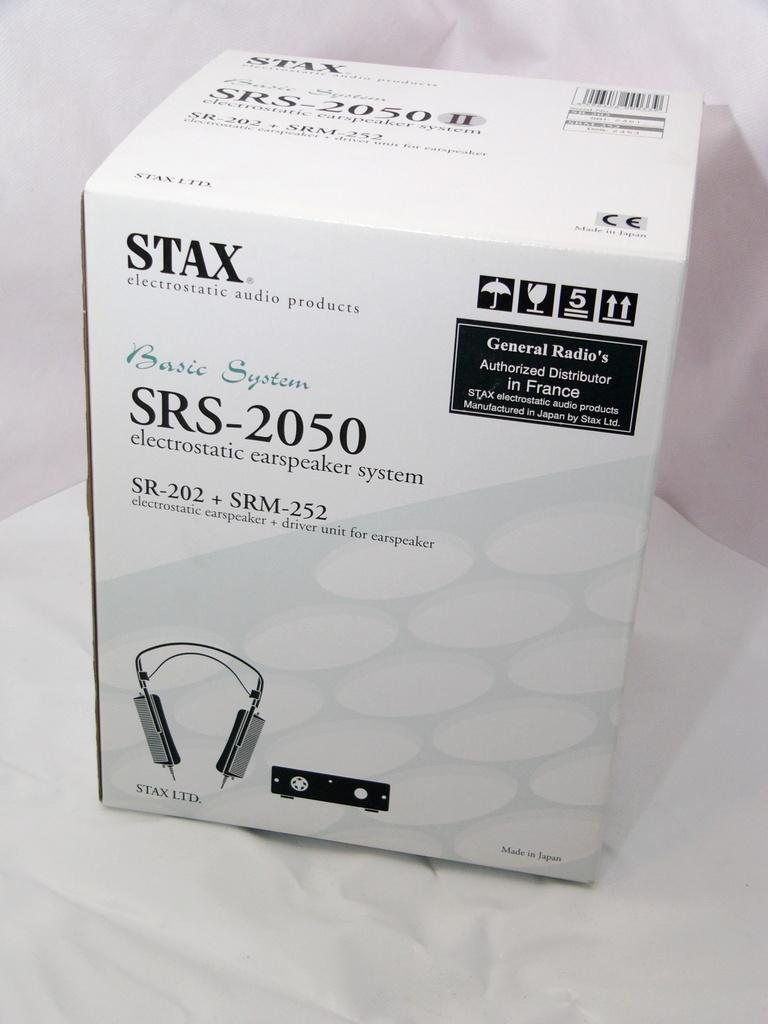<image>
Offer a succinct explanation of the picture presented. A box with audio equipment in it with SRS-2050 on the front. 